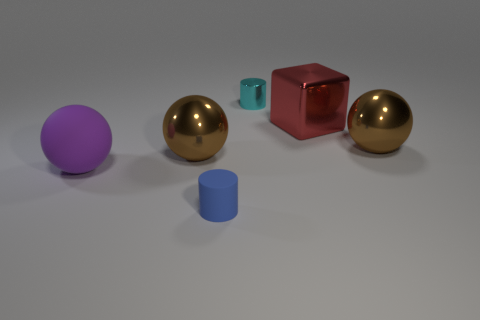Subtract all brown shiny balls. How many balls are left? 1 Subtract 1 cylinders. How many cylinders are left? 1 Add 4 small metallic cylinders. How many objects exist? 10 Subtract all brown balls. How many balls are left? 1 Subtract all gray cubes. Subtract all cyan cylinders. How many cubes are left? 1 Subtract all blue cylinders. How many brown cubes are left? 0 Subtract all small cyan metal cylinders. Subtract all purple matte objects. How many objects are left? 4 Add 2 big brown metal spheres. How many big brown metal spheres are left? 4 Add 2 tiny red matte balls. How many tiny red matte balls exist? 2 Subtract 0 purple cylinders. How many objects are left? 6 